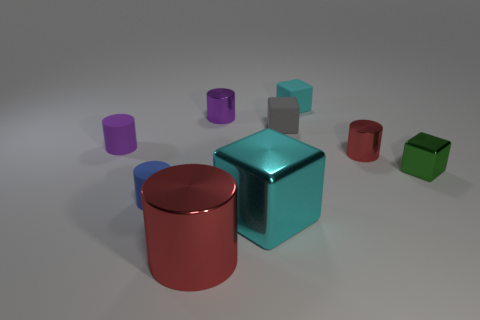What number of gray objects are tiny shiny objects or large matte blocks?
Your response must be concise. 0. Is the number of tiny gray rubber things to the left of the green object greater than the number of yellow metallic cylinders?
Give a very brief answer. Yes. Is the size of the blue matte cylinder the same as the gray rubber object?
Offer a very short reply. Yes. What color is the big block that is the same material as the tiny green block?
Offer a terse response. Cyan. There is a object that is the same color as the large metal block; what shape is it?
Your answer should be compact. Cube. Are there an equal number of red cylinders behind the purple metallic cylinder and metal cylinders behind the tiny green metal object?
Keep it short and to the point. No. What is the shape of the tiny metallic thing in front of the red cylinder behind the large red cylinder?
Your answer should be compact. Cube. There is another purple object that is the same shape as the small purple shiny thing; what material is it?
Your answer should be very brief. Rubber. There is a matte cylinder that is the same size as the blue matte thing; what color is it?
Make the answer very short. Purple. Are there the same number of matte cubes right of the gray object and gray blocks?
Your response must be concise. Yes. 